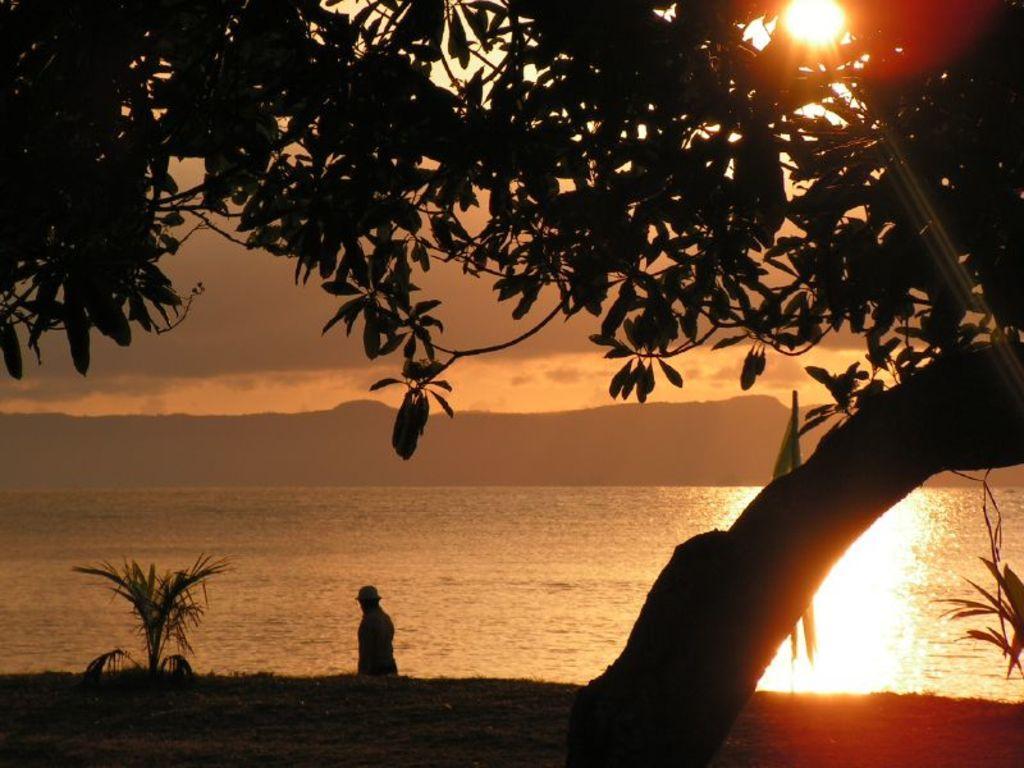In one or two sentences, can you explain what this image depicts? At the bottom of the picture, we see a person is standing. On the left side, we see a plant. Beside her, we see water and this water might be in the river. In front of the picture, we see a tree. At the top, we see the sun. There are hills and the sky in the background. 